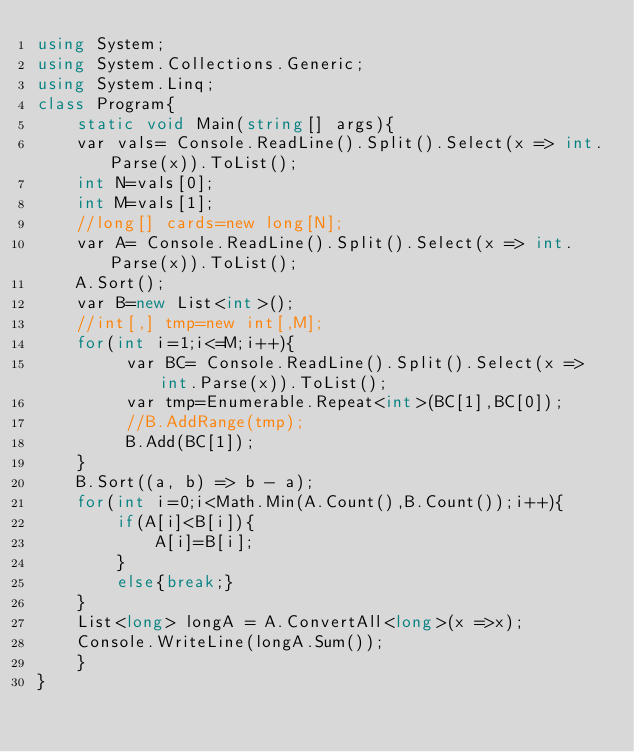<code> <loc_0><loc_0><loc_500><loc_500><_C#_>using System;
using System.Collections.Generic;
using System.Linq;
class Program{
    static void Main(string[] args){
    var vals= Console.ReadLine().Split().Select(x => int.Parse(x)).ToList();
    int N=vals[0];
    int M=vals[1];
    //long[] cards=new long[N];
    var A= Console.ReadLine().Split().Select(x => int.Parse(x)).ToList();
    A.Sort();
    var B=new List<int>();
    //int[,] tmp=new int[,M]; 
    for(int i=1;i<=M;i++){ 
         var BC= Console.ReadLine().Split().Select(x => int.Parse(x)).ToList();
         var tmp=Enumerable.Repeat<int>(BC[1],BC[0]);
         //B.AddRange(tmp);
         B.Add(BC[1]);
    }
    B.Sort((a, b) => b - a);
    for(int i=0;i<Math.Min(A.Count(),B.Count());i++){
        if(A[i]<B[i]){
            A[i]=B[i];
        }
        else{break;}
    }
    List<long> longA = A.ConvertAll<long>(x =>x);
    Console.WriteLine(longA.Sum());
    }
}


</code> 